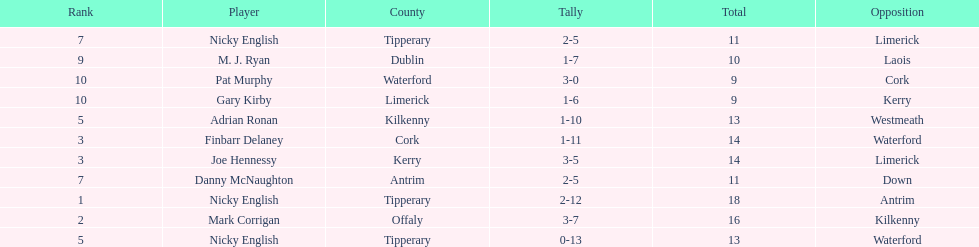Joe hennessy and finbarr delaney both scored how many points? 14. 